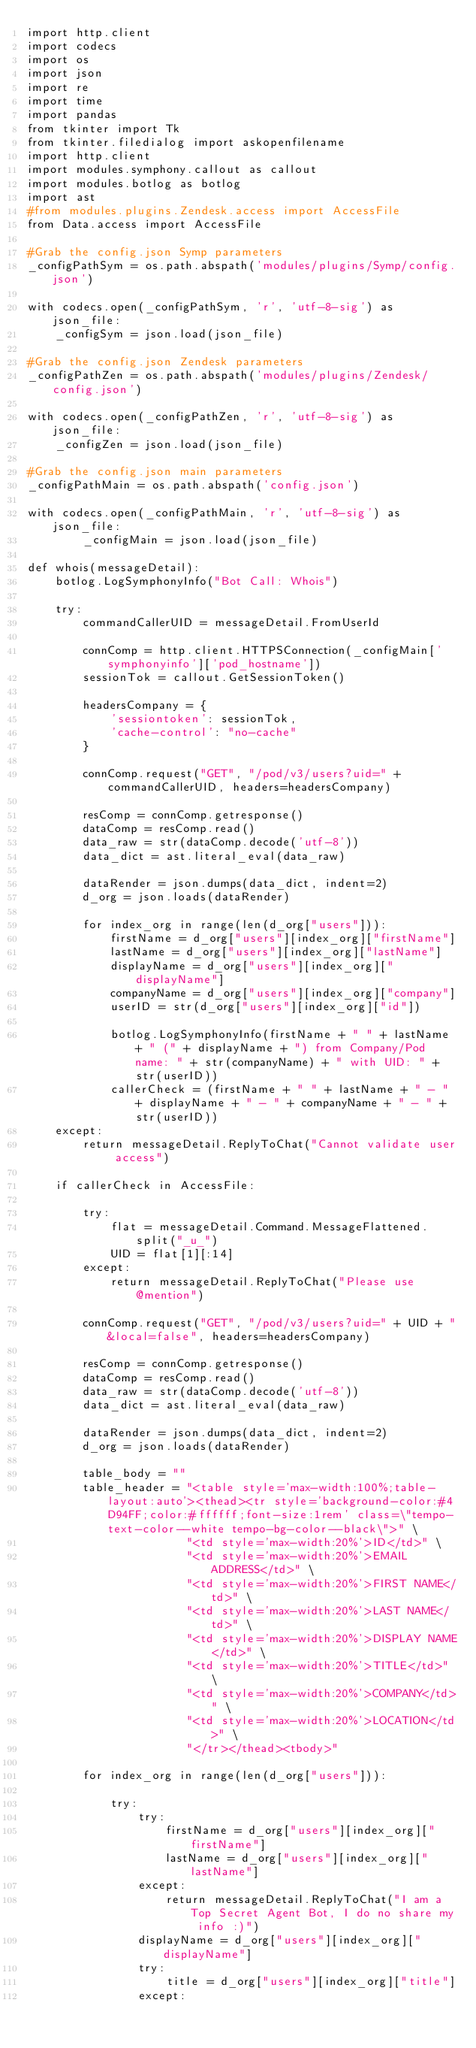Convert code to text. <code><loc_0><loc_0><loc_500><loc_500><_Python_>import http.client
import codecs
import os
import json
import re
import time
import pandas
from tkinter import Tk
from tkinter.filedialog import askopenfilename
import http.client
import modules.symphony.callout as callout
import modules.botlog as botlog
import ast
#from modules.plugins.Zendesk.access import AccessFile
from Data.access import AccessFile

#Grab the config.json Symp parameters
_configPathSym = os.path.abspath('modules/plugins/Symp/config.json')

with codecs.open(_configPathSym, 'r', 'utf-8-sig') as json_file:
    _configSym = json.load(json_file)

#Grab the config.json Zendesk parameters
_configPathZen = os.path.abspath('modules/plugins/Zendesk/config.json')

with codecs.open(_configPathZen, 'r', 'utf-8-sig') as json_file:
    _configZen = json.load(json_file)

#Grab the config.json main parameters
_configPathMain = os.path.abspath('config.json')

with codecs.open(_configPathMain, 'r', 'utf-8-sig') as json_file:
        _configMain = json.load(json_file)

def whois(messageDetail):
    botlog.LogSymphonyInfo("Bot Call: Whois")

    try:
        commandCallerUID = messageDetail.FromUserId

        connComp = http.client.HTTPSConnection(_configMain['symphonyinfo']['pod_hostname'])
        sessionTok = callout.GetSessionToken()

        headersCompany = {
            'sessiontoken': sessionTok,
            'cache-control': "no-cache"
        }

        connComp.request("GET", "/pod/v3/users?uid=" + commandCallerUID, headers=headersCompany)

        resComp = connComp.getresponse()
        dataComp = resComp.read()
        data_raw = str(dataComp.decode('utf-8'))
        data_dict = ast.literal_eval(data_raw)

        dataRender = json.dumps(data_dict, indent=2)
        d_org = json.loads(dataRender)

        for index_org in range(len(d_org["users"])):
            firstName = d_org["users"][index_org]["firstName"]
            lastName = d_org["users"][index_org]["lastName"]
            displayName = d_org["users"][index_org]["displayName"]
            companyName = d_org["users"][index_org]["company"]
            userID = str(d_org["users"][index_org]["id"])

            botlog.LogSymphonyInfo(firstName + " " + lastName + " (" + displayName + ") from Company/Pod name: " + str(companyName) + " with UID: " + str(userID))
            callerCheck = (firstName + " " + lastName + " - " + displayName + " - " + companyName + " - " + str(userID))
    except:
        return messageDetail.ReplyToChat("Cannot validate user access")

    if callerCheck in AccessFile:

        try:
            flat = messageDetail.Command.MessageFlattened.split("_u_")
            UID = flat[1][:14]
        except:
            return messageDetail.ReplyToChat("Please use @mention")

        connComp.request("GET", "/pod/v3/users?uid=" + UID + "&local=false", headers=headersCompany)

        resComp = connComp.getresponse()
        dataComp = resComp.read()
        data_raw = str(dataComp.decode('utf-8'))
        data_dict = ast.literal_eval(data_raw)

        dataRender = json.dumps(data_dict, indent=2)
        d_org = json.loads(dataRender)

        table_body = ""
        table_header = "<table style='max-width:100%;table-layout:auto'><thead><tr style='background-color:#4D94FF;color:#ffffff;font-size:1rem' class=\"tempo-text-color--white tempo-bg-color--black\">" \
                       "<td style='max-width:20%'>ID</td>" \
                       "<td style='max-width:20%'>EMAIL ADDRESS</td>" \
                       "<td style='max-width:20%'>FIRST NAME</td>" \
                       "<td style='max-width:20%'>LAST NAME</td>" \
                       "<td style='max-width:20%'>DISPLAY NAME</td>" \
                       "<td style='max-width:20%'>TITLE</td>" \
                       "<td style='max-width:20%'>COMPANY</td>" \
                       "<td style='max-width:20%'>LOCATION</td>" \
                       "</tr></thead><tbody>"

        for index_org in range(len(d_org["users"])):

            try:
                try:
                    firstName = d_org["users"][index_org]["firstName"]
                    lastName = d_org["users"][index_org]["lastName"]
                except:
                    return messageDetail.ReplyToChat("I am a Top Secret Agent Bot, I do no share my info :)")
                displayName = d_org["users"][index_org]["displayName"]
                try:
                    title = d_org["users"][index_org]["title"]
                except:</code> 